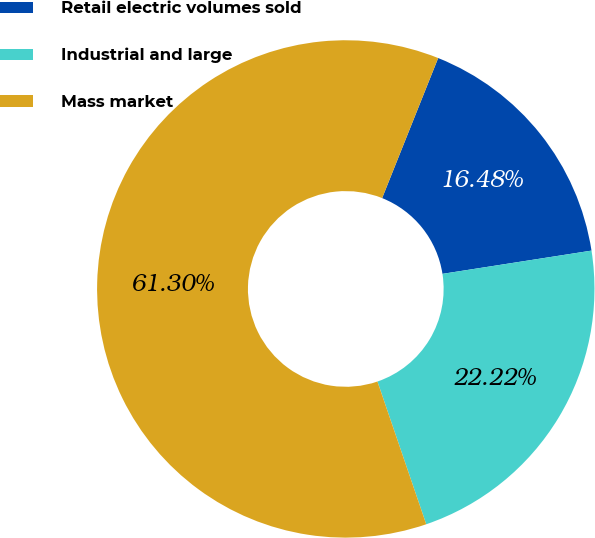Convert chart to OTSL. <chart><loc_0><loc_0><loc_500><loc_500><pie_chart><fcel>Retail electric volumes sold<fcel>Industrial and large<fcel>Mass market<nl><fcel>16.48%<fcel>22.22%<fcel>61.3%<nl></chart> 